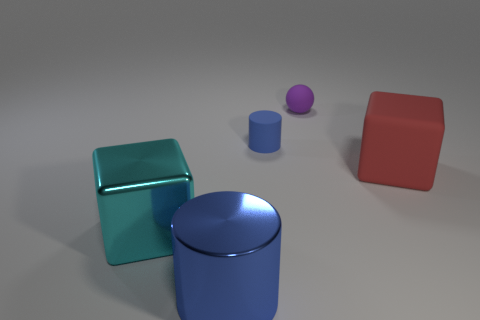Add 3 small matte things. How many objects exist? 8 Subtract all blocks. How many objects are left? 3 Add 4 blue cylinders. How many blue cylinders exist? 6 Subtract 1 red cubes. How many objects are left? 4 Subtract all tiny green metal blocks. Subtract all big cyan objects. How many objects are left? 4 Add 4 big blue metallic objects. How many big blue metallic objects are left? 5 